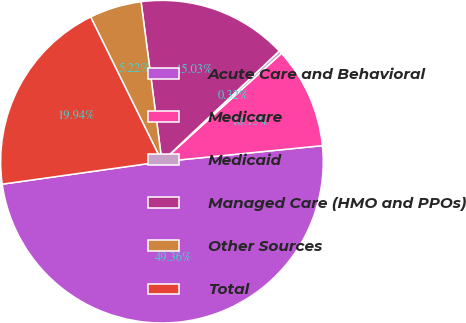<chart> <loc_0><loc_0><loc_500><loc_500><pie_chart><fcel>Acute Care and Behavioral<fcel>Medicare<fcel>Medicaid<fcel>Managed Care (HMO and PPOs)<fcel>Other Sources<fcel>Total<nl><fcel>49.36%<fcel>10.13%<fcel>0.32%<fcel>15.03%<fcel>5.22%<fcel>19.94%<nl></chart> 